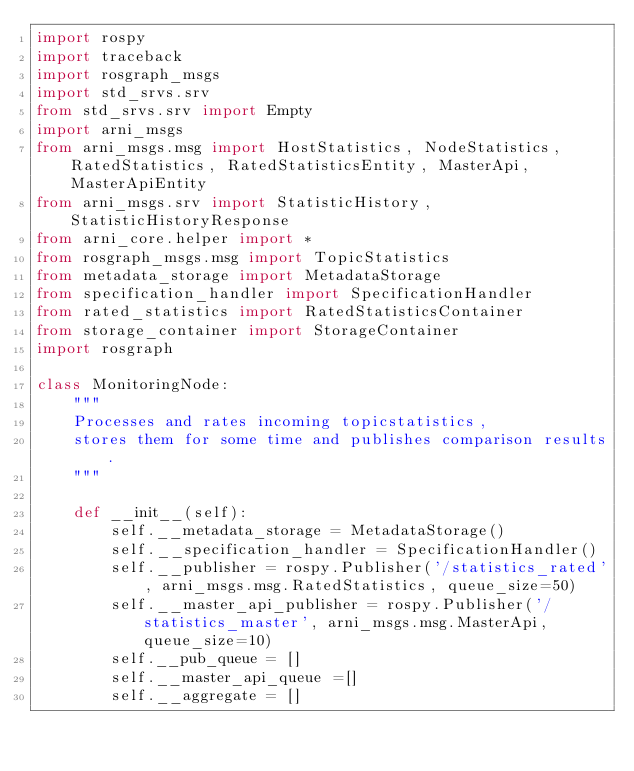<code> <loc_0><loc_0><loc_500><loc_500><_Python_>import rospy
import traceback
import rosgraph_msgs
import std_srvs.srv
from std_srvs.srv import Empty
import arni_msgs
from arni_msgs.msg import HostStatistics, NodeStatistics, RatedStatistics, RatedStatisticsEntity, MasterApi, MasterApiEntity
from arni_msgs.srv import StatisticHistory, StatisticHistoryResponse
from arni_core.helper import *
from rosgraph_msgs.msg import TopicStatistics
from metadata_storage import MetadataStorage
from specification_handler import SpecificationHandler
from rated_statistics import RatedStatisticsContainer
from storage_container import StorageContainer
import rosgraph

class MonitoringNode:
    """
    Processes and rates incoming topicstatistics,
    stores them for some time and publishes comparison results.
    """

    def __init__(self):
        self.__metadata_storage = MetadataStorage()
        self.__specification_handler = SpecificationHandler()
        self.__publisher = rospy.Publisher('/statistics_rated', arni_msgs.msg.RatedStatistics, queue_size=50)
        self.__master_api_publisher = rospy.Publisher('/statistics_master', arni_msgs.msg.MasterApi, queue_size=10)
        self.__pub_queue = []
        self.__master_api_queue =[]
        self.__aggregate = []</code> 